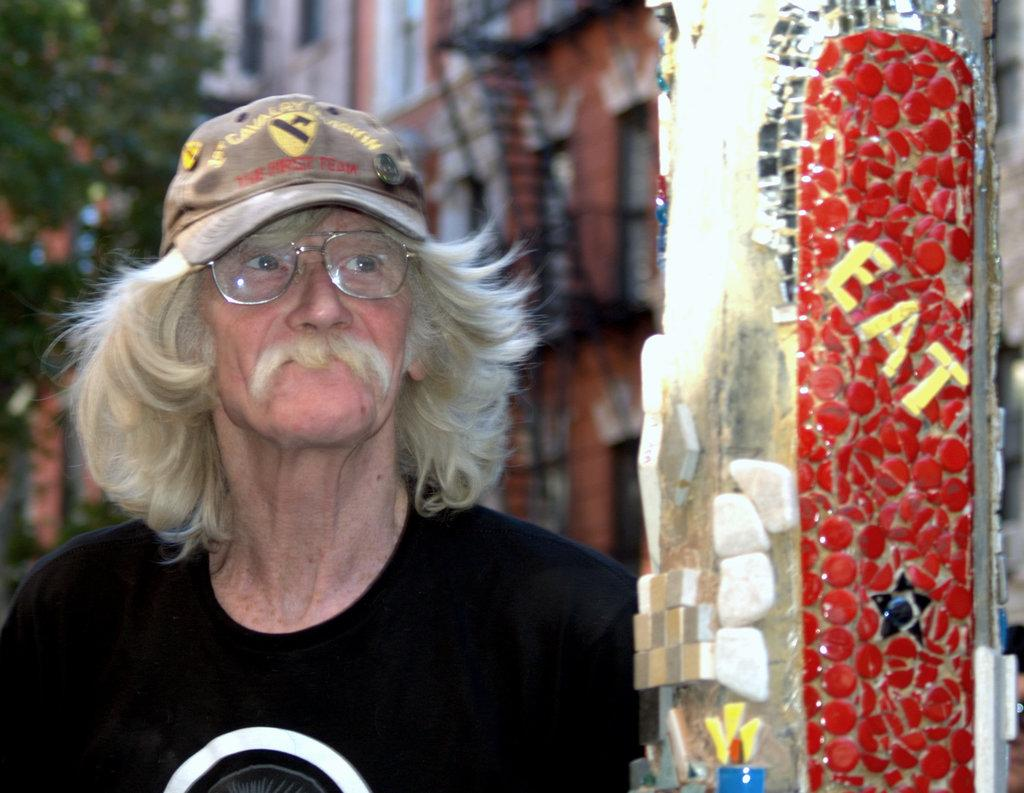What is the main subject of the image? There is a person in the image. What can be seen on the pole in the image? There are letters and other objects on the pole in the image. What is visible in the background of the image? There are buildings and trees in the background of the image. What type of pan is being used to give advice to the person in the image? There is no pan or advice-giving in the image; it only features a person, a pole with letters and objects, and a background with buildings and trees. 